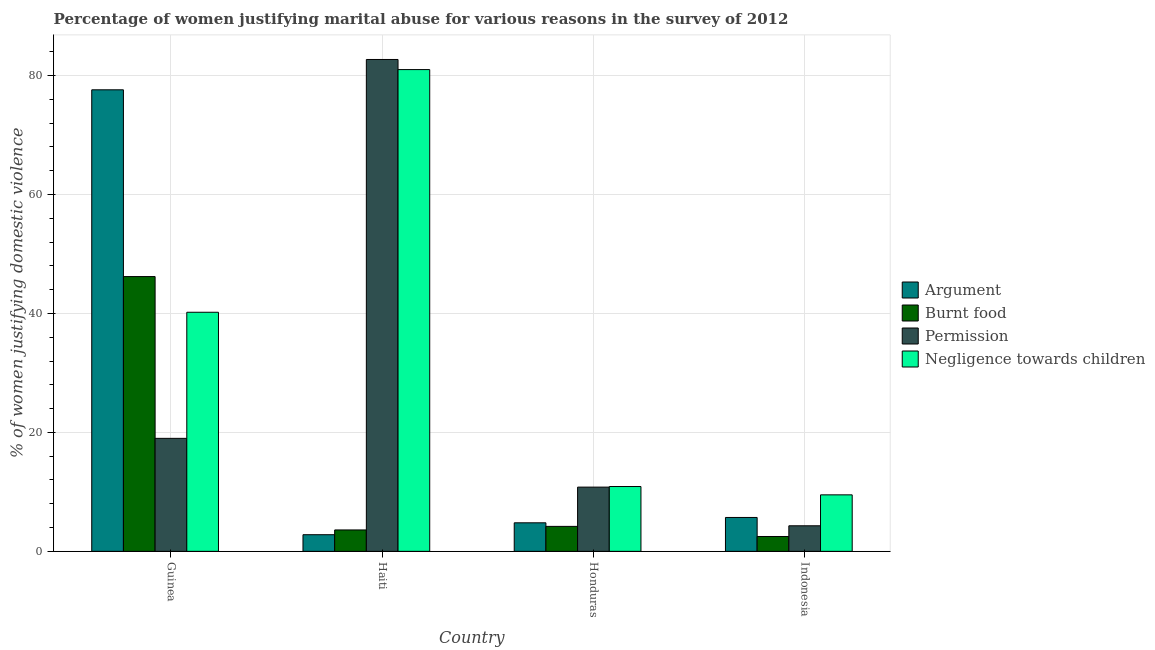Are the number of bars per tick equal to the number of legend labels?
Provide a succinct answer. Yes. Are the number of bars on each tick of the X-axis equal?
Keep it short and to the point. Yes. How many bars are there on the 1st tick from the left?
Your answer should be compact. 4. How many bars are there on the 3rd tick from the right?
Give a very brief answer. 4. What is the label of the 1st group of bars from the left?
Your answer should be very brief. Guinea. What is the percentage of women justifying abuse for going without permission in Haiti?
Make the answer very short. 82.7. Across all countries, what is the maximum percentage of women justifying abuse for showing negligence towards children?
Keep it short and to the point. 81. In which country was the percentage of women justifying abuse for burning food maximum?
Your answer should be very brief. Guinea. What is the total percentage of women justifying abuse in the case of an argument in the graph?
Offer a very short reply. 90.9. What is the difference between the percentage of women justifying abuse for burning food in Guinea and that in Haiti?
Your answer should be compact. 42.6. What is the difference between the percentage of women justifying abuse for burning food in Indonesia and the percentage of women justifying abuse in the case of an argument in Guinea?
Offer a terse response. -75.1. What is the average percentage of women justifying abuse in the case of an argument per country?
Ensure brevity in your answer.  22.72. What is the difference between the percentage of women justifying abuse for burning food and percentage of women justifying abuse in the case of an argument in Haiti?
Offer a terse response. 0.8. What is the ratio of the percentage of women justifying abuse for burning food in Guinea to that in Honduras?
Your answer should be compact. 11. What is the difference between the highest and the second highest percentage of women justifying abuse in the case of an argument?
Keep it short and to the point. 71.9. What is the difference between the highest and the lowest percentage of women justifying abuse in the case of an argument?
Keep it short and to the point. 74.8. Is it the case that in every country, the sum of the percentage of women justifying abuse for going without permission and percentage of women justifying abuse in the case of an argument is greater than the sum of percentage of women justifying abuse for burning food and percentage of women justifying abuse for showing negligence towards children?
Provide a short and direct response. No. What does the 4th bar from the left in Indonesia represents?
Give a very brief answer. Negligence towards children. What does the 3rd bar from the right in Indonesia represents?
Make the answer very short. Burnt food. How many countries are there in the graph?
Your answer should be compact. 4. Are the values on the major ticks of Y-axis written in scientific E-notation?
Give a very brief answer. No. Where does the legend appear in the graph?
Your response must be concise. Center right. How many legend labels are there?
Provide a succinct answer. 4. How are the legend labels stacked?
Give a very brief answer. Vertical. What is the title of the graph?
Ensure brevity in your answer.  Percentage of women justifying marital abuse for various reasons in the survey of 2012. Does "Switzerland" appear as one of the legend labels in the graph?
Your response must be concise. No. What is the label or title of the X-axis?
Offer a very short reply. Country. What is the label or title of the Y-axis?
Your response must be concise. % of women justifying domestic violence. What is the % of women justifying domestic violence in Argument in Guinea?
Your response must be concise. 77.6. What is the % of women justifying domestic violence in Burnt food in Guinea?
Provide a short and direct response. 46.2. What is the % of women justifying domestic violence of Negligence towards children in Guinea?
Your response must be concise. 40.2. What is the % of women justifying domestic violence of Burnt food in Haiti?
Provide a short and direct response. 3.6. What is the % of women justifying domestic violence of Permission in Haiti?
Provide a succinct answer. 82.7. What is the % of women justifying domestic violence in Burnt food in Indonesia?
Keep it short and to the point. 2.5. What is the % of women justifying domestic violence in Permission in Indonesia?
Your answer should be very brief. 4.3. What is the % of women justifying domestic violence in Negligence towards children in Indonesia?
Make the answer very short. 9.5. Across all countries, what is the maximum % of women justifying domestic violence of Argument?
Offer a very short reply. 77.6. Across all countries, what is the maximum % of women justifying domestic violence of Burnt food?
Provide a succinct answer. 46.2. Across all countries, what is the maximum % of women justifying domestic violence of Permission?
Make the answer very short. 82.7. Across all countries, what is the maximum % of women justifying domestic violence in Negligence towards children?
Your answer should be compact. 81. Across all countries, what is the minimum % of women justifying domestic violence in Argument?
Provide a short and direct response. 2.8. Across all countries, what is the minimum % of women justifying domestic violence in Burnt food?
Keep it short and to the point. 2.5. Across all countries, what is the minimum % of women justifying domestic violence in Permission?
Give a very brief answer. 4.3. Across all countries, what is the minimum % of women justifying domestic violence in Negligence towards children?
Your response must be concise. 9.5. What is the total % of women justifying domestic violence of Argument in the graph?
Your response must be concise. 90.9. What is the total % of women justifying domestic violence of Burnt food in the graph?
Ensure brevity in your answer.  56.5. What is the total % of women justifying domestic violence in Permission in the graph?
Provide a short and direct response. 116.8. What is the total % of women justifying domestic violence in Negligence towards children in the graph?
Your response must be concise. 141.6. What is the difference between the % of women justifying domestic violence in Argument in Guinea and that in Haiti?
Make the answer very short. 74.8. What is the difference between the % of women justifying domestic violence of Burnt food in Guinea and that in Haiti?
Your answer should be very brief. 42.6. What is the difference between the % of women justifying domestic violence of Permission in Guinea and that in Haiti?
Provide a succinct answer. -63.7. What is the difference between the % of women justifying domestic violence in Negligence towards children in Guinea and that in Haiti?
Your answer should be compact. -40.8. What is the difference between the % of women justifying domestic violence of Argument in Guinea and that in Honduras?
Provide a short and direct response. 72.8. What is the difference between the % of women justifying domestic violence of Negligence towards children in Guinea and that in Honduras?
Make the answer very short. 29.3. What is the difference between the % of women justifying domestic violence of Argument in Guinea and that in Indonesia?
Offer a terse response. 71.9. What is the difference between the % of women justifying domestic violence of Burnt food in Guinea and that in Indonesia?
Your answer should be very brief. 43.7. What is the difference between the % of women justifying domestic violence in Permission in Guinea and that in Indonesia?
Keep it short and to the point. 14.7. What is the difference between the % of women justifying domestic violence of Negligence towards children in Guinea and that in Indonesia?
Your answer should be very brief. 30.7. What is the difference between the % of women justifying domestic violence of Argument in Haiti and that in Honduras?
Give a very brief answer. -2. What is the difference between the % of women justifying domestic violence in Permission in Haiti and that in Honduras?
Provide a succinct answer. 71.9. What is the difference between the % of women justifying domestic violence in Negligence towards children in Haiti and that in Honduras?
Your answer should be compact. 70.1. What is the difference between the % of women justifying domestic violence in Argument in Haiti and that in Indonesia?
Your answer should be very brief. -2.9. What is the difference between the % of women justifying domestic violence in Permission in Haiti and that in Indonesia?
Offer a terse response. 78.4. What is the difference between the % of women justifying domestic violence in Negligence towards children in Haiti and that in Indonesia?
Your response must be concise. 71.5. What is the difference between the % of women justifying domestic violence in Argument in Honduras and that in Indonesia?
Give a very brief answer. -0.9. What is the difference between the % of women justifying domestic violence of Argument in Guinea and the % of women justifying domestic violence of Burnt food in Haiti?
Your answer should be compact. 74. What is the difference between the % of women justifying domestic violence of Argument in Guinea and the % of women justifying domestic violence of Negligence towards children in Haiti?
Give a very brief answer. -3.4. What is the difference between the % of women justifying domestic violence of Burnt food in Guinea and the % of women justifying domestic violence of Permission in Haiti?
Ensure brevity in your answer.  -36.5. What is the difference between the % of women justifying domestic violence in Burnt food in Guinea and the % of women justifying domestic violence in Negligence towards children in Haiti?
Your response must be concise. -34.8. What is the difference between the % of women justifying domestic violence in Permission in Guinea and the % of women justifying domestic violence in Negligence towards children in Haiti?
Provide a short and direct response. -62. What is the difference between the % of women justifying domestic violence of Argument in Guinea and the % of women justifying domestic violence of Burnt food in Honduras?
Your answer should be compact. 73.4. What is the difference between the % of women justifying domestic violence in Argument in Guinea and the % of women justifying domestic violence in Permission in Honduras?
Provide a succinct answer. 66.8. What is the difference between the % of women justifying domestic violence of Argument in Guinea and the % of women justifying domestic violence of Negligence towards children in Honduras?
Ensure brevity in your answer.  66.7. What is the difference between the % of women justifying domestic violence of Burnt food in Guinea and the % of women justifying domestic violence of Permission in Honduras?
Your answer should be compact. 35.4. What is the difference between the % of women justifying domestic violence of Burnt food in Guinea and the % of women justifying domestic violence of Negligence towards children in Honduras?
Ensure brevity in your answer.  35.3. What is the difference between the % of women justifying domestic violence of Permission in Guinea and the % of women justifying domestic violence of Negligence towards children in Honduras?
Provide a short and direct response. 8.1. What is the difference between the % of women justifying domestic violence in Argument in Guinea and the % of women justifying domestic violence in Burnt food in Indonesia?
Your response must be concise. 75.1. What is the difference between the % of women justifying domestic violence in Argument in Guinea and the % of women justifying domestic violence in Permission in Indonesia?
Give a very brief answer. 73.3. What is the difference between the % of women justifying domestic violence in Argument in Guinea and the % of women justifying domestic violence in Negligence towards children in Indonesia?
Provide a short and direct response. 68.1. What is the difference between the % of women justifying domestic violence in Burnt food in Guinea and the % of women justifying domestic violence in Permission in Indonesia?
Offer a terse response. 41.9. What is the difference between the % of women justifying domestic violence in Burnt food in Guinea and the % of women justifying domestic violence in Negligence towards children in Indonesia?
Provide a short and direct response. 36.7. What is the difference between the % of women justifying domestic violence in Permission in Guinea and the % of women justifying domestic violence in Negligence towards children in Indonesia?
Make the answer very short. 9.5. What is the difference between the % of women justifying domestic violence in Argument in Haiti and the % of women justifying domestic violence in Permission in Honduras?
Give a very brief answer. -8. What is the difference between the % of women justifying domestic violence of Burnt food in Haiti and the % of women justifying domestic violence of Permission in Honduras?
Offer a terse response. -7.2. What is the difference between the % of women justifying domestic violence in Burnt food in Haiti and the % of women justifying domestic violence in Negligence towards children in Honduras?
Provide a short and direct response. -7.3. What is the difference between the % of women justifying domestic violence of Permission in Haiti and the % of women justifying domestic violence of Negligence towards children in Honduras?
Offer a terse response. 71.8. What is the difference between the % of women justifying domestic violence in Burnt food in Haiti and the % of women justifying domestic violence in Permission in Indonesia?
Your answer should be very brief. -0.7. What is the difference between the % of women justifying domestic violence in Permission in Haiti and the % of women justifying domestic violence in Negligence towards children in Indonesia?
Give a very brief answer. 73.2. What is the difference between the % of women justifying domestic violence in Argument in Honduras and the % of women justifying domestic violence in Permission in Indonesia?
Your answer should be compact. 0.5. What is the difference between the % of women justifying domestic violence of Burnt food in Honduras and the % of women justifying domestic violence of Permission in Indonesia?
Ensure brevity in your answer.  -0.1. What is the difference between the % of women justifying domestic violence in Burnt food in Honduras and the % of women justifying domestic violence in Negligence towards children in Indonesia?
Your answer should be compact. -5.3. What is the average % of women justifying domestic violence of Argument per country?
Offer a very short reply. 22.73. What is the average % of women justifying domestic violence of Burnt food per country?
Offer a terse response. 14.12. What is the average % of women justifying domestic violence of Permission per country?
Your response must be concise. 29.2. What is the average % of women justifying domestic violence of Negligence towards children per country?
Offer a very short reply. 35.4. What is the difference between the % of women justifying domestic violence in Argument and % of women justifying domestic violence in Burnt food in Guinea?
Your answer should be very brief. 31.4. What is the difference between the % of women justifying domestic violence in Argument and % of women justifying domestic violence in Permission in Guinea?
Provide a short and direct response. 58.6. What is the difference between the % of women justifying domestic violence of Argument and % of women justifying domestic violence of Negligence towards children in Guinea?
Give a very brief answer. 37.4. What is the difference between the % of women justifying domestic violence of Burnt food and % of women justifying domestic violence of Permission in Guinea?
Your answer should be very brief. 27.2. What is the difference between the % of women justifying domestic violence in Permission and % of women justifying domestic violence in Negligence towards children in Guinea?
Provide a succinct answer. -21.2. What is the difference between the % of women justifying domestic violence of Argument and % of women justifying domestic violence of Permission in Haiti?
Your answer should be compact. -79.9. What is the difference between the % of women justifying domestic violence of Argument and % of women justifying domestic violence of Negligence towards children in Haiti?
Keep it short and to the point. -78.2. What is the difference between the % of women justifying domestic violence in Burnt food and % of women justifying domestic violence in Permission in Haiti?
Your response must be concise. -79.1. What is the difference between the % of women justifying domestic violence of Burnt food and % of women justifying domestic violence of Negligence towards children in Haiti?
Provide a short and direct response. -77.4. What is the difference between the % of women justifying domestic violence in Argument and % of women justifying domestic violence in Burnt food in Honduras?
Give a very brief answer. 0.6. What is the difference between the % of women justifying domestic violence of Argument and % of women justifying domestic violence of Permission in Honduras?
Provide a succinct answer. -6. What is the difference between the % of women justifying domestic violence in Burnt food and % of women justifying domestic violence in Permission in Honduras?
Offer a very short reply. -6.6. What is the difference between the % of women justifying domestic violence of Permission and % of women justifying domestic violence of Negligence towards children in Honduras?
Provide a short and direct response. -0.1. What is the difference between the % of women justifying domestic violence of Burnt food and % of women justifying domestic violence of Permission in Indonesia?
Your response must be concise. -1.8. What is the ratio of the % of women justifying domestic violence of Argument in Guinea to that in Haiti?
Your response must be concise. 27.71. What is the ratio of the % of women justifying domestic violence in Burnt food in Guinea to that in Haiti?
Offer a very short reply. 12.83. What is the ratio of the % of women justifying domestic violence in Permission in Guinea to that in Haiti?
Your answer should be compact. 0.23. What is the ratio of the % of women justifying domestic violence in Negligence towards children in Guinea to that in Haiti?
Provide a short and direct response. 0.5. What is the ratio of the % of women justifying domestic violence in Argument in Guinea to that in Honduras?
Offer a very short reply. 16.17. What is the ratio of the % of women justifying domestic violence in Permission in Guinea to that in Honduras?
Offer a very short reply. 1.76. What is the ratio of the % of women justifying domestic violence in Negligence towards children in Guinea to that in Honduras?
Offer a terse response. 3.69. What is the ratio of the % of women justifying domestic violence in Argument in Guinea to that in Indonesia?
Offer a very short reply. 13.61. What is the ratio of the % of women justifying domestic violence of Burnt food in Guinea to that in Indonesia?
Give a very brief answer. 18.48. What is the ratio of the % of women justifying domestic violence in Permission in Guinea to that in Indonesia?
Ensure brevity in your answer.  4.42. What is the ratio of the % of women justifying domestic violence of Negligence towards children in Guinea to that in Indonesia?
Keep it short and to the point. 4.23. What is the ratio of the % of women justifying domestic violence in Argument in Haiti to that in Honduras?
Offer a terse response. 0.58. What is the ratio of the % of women justifying domestic violence of Burnt food in Haiti to that in Honduras?
Keep it short and to the point. 0.86. What is the ratio of the % of women justifying domestic violence in Permission in Haiti to that in Honduras?
Provide a short and direct response. 7.66. What is the ratio of the % of women justifying domestic violence in Negligence towards children in Haiti to that in Honduras?
Your answer should be very brief. 7.43. What is the ratio of the % of women justifying domestic violence of Argument in Haiti to that in Indonesia?
Your answer should be compact. 0.49. What is the ratio of the % of women justifying domestic violence in Burnt food in Haiti to that in Indonesia?
Provide a succinct answer. 1.44. What is the ratio of the % of women justifying domestic violence in Permission in Haiti to that in Indonesia?
Keep it short and to the point. 19.23. What is the ratio of the % of women justifying domestic violence of Negligence towards children in Haiti to that in Indonesia?
Your response must be concise. 8.53. What is the ratio of the % of women justifying domestic violence in Argument in Honduras to that in Indonesia?
Offer a terse response. 0.84. What is the ratio of the % of women justifying domestic violence in Burnt food in Honduras to that in Indonesia?
Your response must be concise. 1.68. What is the ratio of the % of women justifying domestic violence of Permission in Honduras to that in Indonesia?
Ensure brevity in your answer.  2.51. What is the ratio of the % of women justifying domestic violence in Negligence towards children in Honduras to that in Indonesia?
Offer a very short reply. 1.15. What is the difference between the highest and the second highest % of women justifying domestic violence of Argument?
Ensure brevity in your answer.  71.9. What is the difference between the highest and the second highest % of women justifying domestic violence in Permission?
Provide a short and direct response. 63.7. What is the difference between the highest and the second highest % of women justifying domestic violence of Negligence towards children?
Ensure brevity in your answer.  40.8. What is the difference between the highest and the lowest % of women justifying domestic violence in Argument?
Provide a short and direct response. 74.8. What is the difference between the highest and the lowest % of women justifying domestic violence in Burnt food?
Ensure brevity in your answer.  43.7. What is the difference between the highest and the lowest % of women justifying domestic violence of Permission?
Offer a very short reply. 78.4. What is the difference between the highest and the lowest % of women justifying domestic violence of Negligence towards children?
Ensure brevity in your answer.  71.5. 